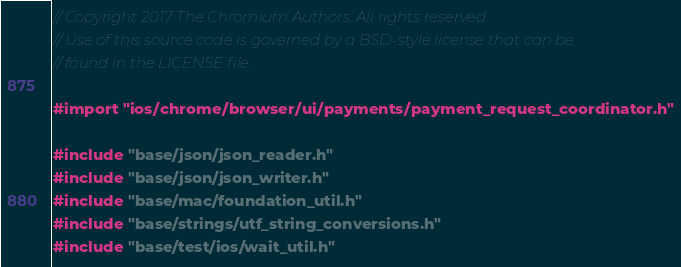Convert code to text. <code><loc_0><loc_0><loc_500><loc_500><_ObjectiveC_>// Copyright 2017 The Chromium Authors. All rights reserved.
// Use of this source code is governed by a BSD-style license that can be
// found in the LICENSE file.

#import "ios/chrome/browser/ui/payments/payment_request_coordinator.h"

#include "base/json/json_reader.h"
#include "base/json/json_writer.h"
#include "base/mac/foundation_util.h"
#include "base/strings/utf_string_conversions.h"
#include "base/test/ios/wait_util.h"</code> 